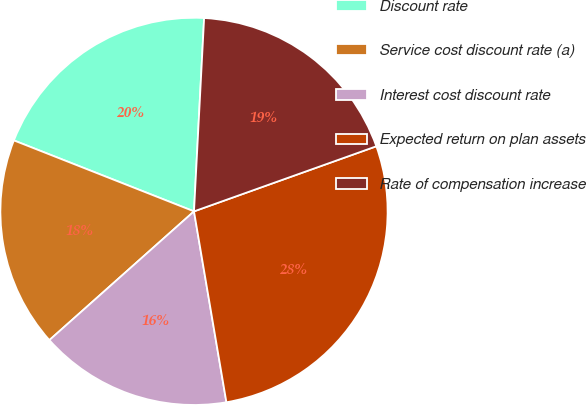<chart> <loc_0><loc_0><loc_500><loc_500><pie_chart><fcel>Discount rate<fcel>Service cost discount rate (a)<fcel>Interest cost discount rate<fcel>Expected return on plan assets<fcel>Rate of compensation increase<nl><fcel>19.86%<fcel>17.55%<fcel>16.1%<fcel>27.78%<fcel>18.71%<nl></chart> 